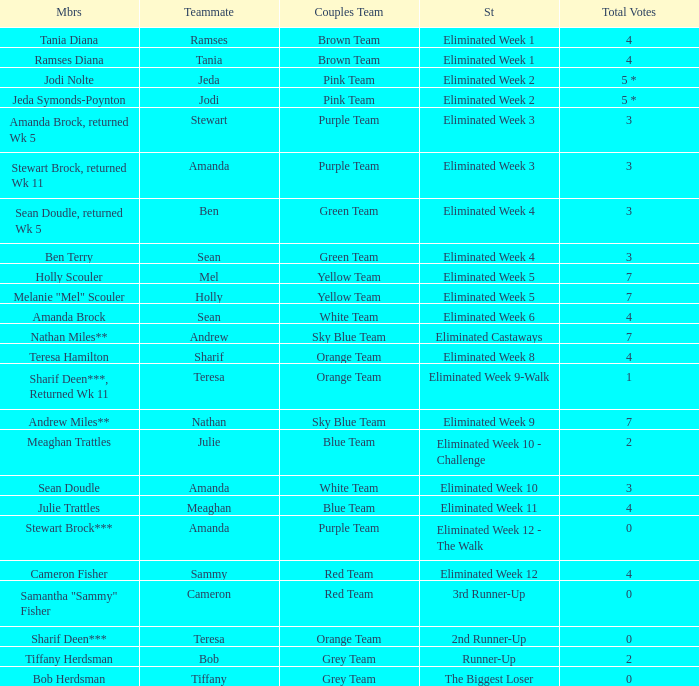What were Holly Scouler's total votes? 7.0. 